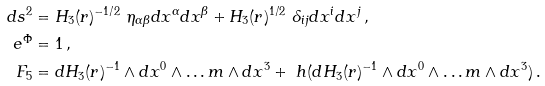Convert formula to latex. <formula><loc_0><loc_0><loc_500><loc_500>d s ^ { 2 } & = H _ { 3 } ( r ) ^ { - 1 / 2 } \ \eta _ { \alpha \beta } d x ^ { \alpha } d x ^ { \beta } + H _ { 3 } ( r ) ^ { 1 / 2 } \ \delta _ { i j } d x ^ { i } d x ^ { j } \, , \\ e ^ { \Phi } & = 1 \, , \\ F _ { 5 } & = d H _ { 3 } ( r ) ^ { - 1 } \wedge d x ^ { 0 } \wedge \dots m \wedge d x ^ { 3 } + \ h ( d H _ { 3 } ( r ) ^ { - 1 } \wedge d x ^ { 0 } \wedge \dots m \wedge d x ^ { 3 } ) \, .</formula> 